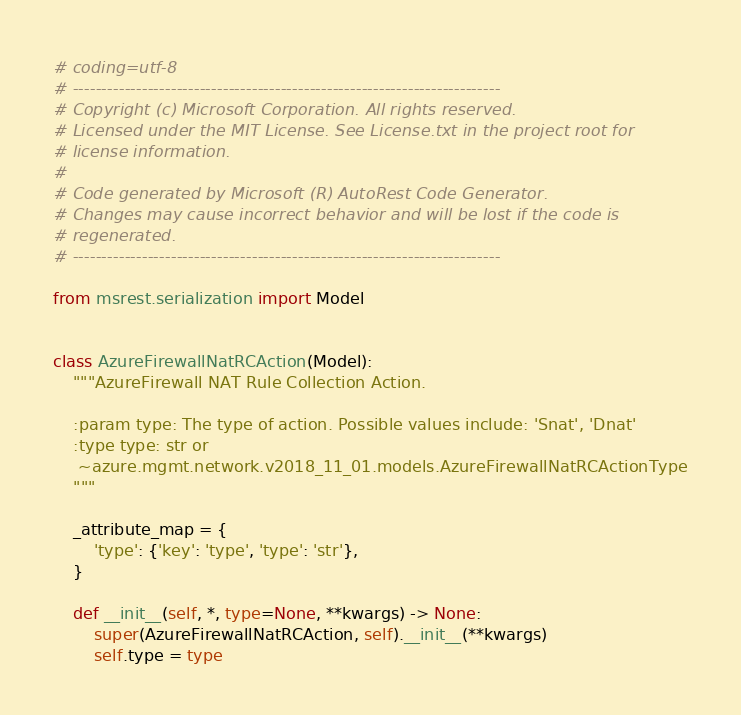<code> <loc_0><loc_0><loc_500><loc_500><_Python_># coding=utf-8
# --------------------------------------------------------------------------
# Copyright (c) Microsoft Corporation. All rights reserved.
# Licensed under the MIT License. See License.txt in the project root for
# license information.
#
# Code generated by Microsoft (R) AutoRest Code Generator.
# Changes may cause incorrect behavior and will be lost if the code is
# regenerated.
# --------------------------------------------------------------------------

from msrest.serialization import Model


class AzureFirewallNatRCAction(Model):
    """AzureFirewall NAT Rule Collection Action.

    :param type: The type of action. Possible values include: 'Snat', 'Dnat'
    :type type: str or
     ~azure.mgmt.network.v2018_11_01.models.AzureFirewallNatRCActionType
    """

    _attribute_map = {
        'type': {'key': 'type', 'type': 'str'},
    }

    def __init__(self, *, type=None, **kwargs) -> None:
        super(AzureFirewallNatRCAction, self).__init__(**kwargs)
        self.type = type
</code> 